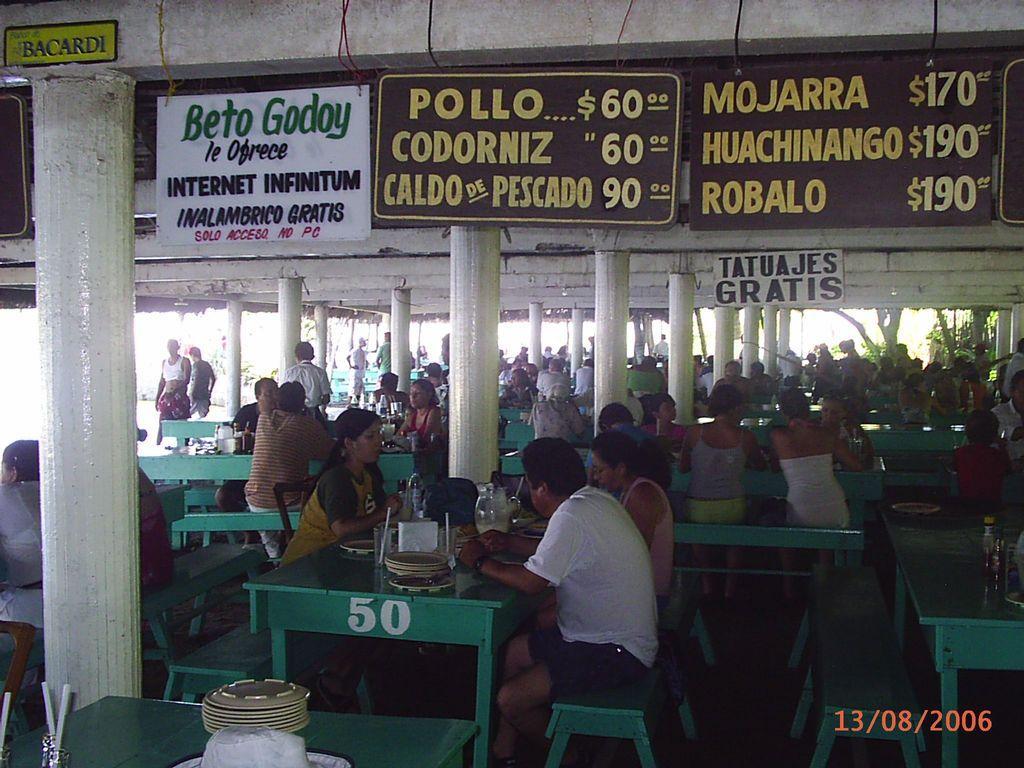In one or two sentences, can you explain what this image depicts? In this image i can see number of people sitting on benches in front of dining table, On the table i can see few plates, a jar and few glasses. In the background i can see few people standing, few dollars and few boards, i can also see few trees. 